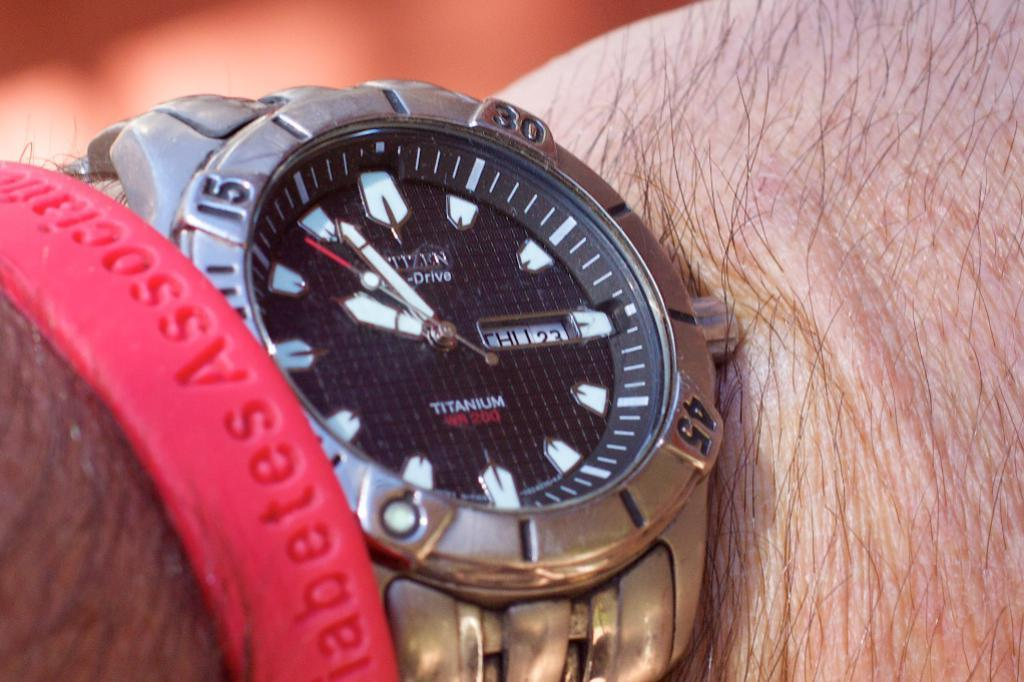<image>
Provide a brief description of the given image. A person is wearing a titanium watch along with a red rubber bracelet. 